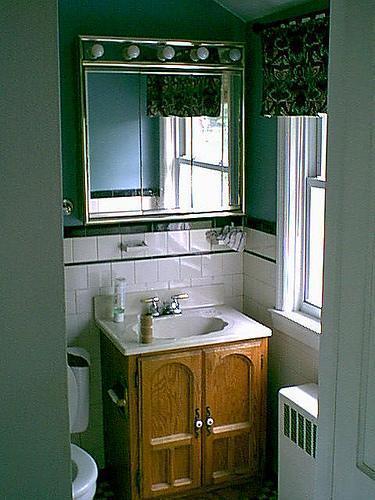How many toilets are shown?
Give a very brief answer. 1. How many light bulbs are above the mirror?
Give a very brief answer. 5. How many windows are in this room?
Give a very brief answer. 1. How many women are wearing blue scarfs?
Give a very brief answer. 0. 